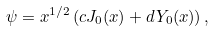<formula> <loc_0><loc_0><loc_500><loc_500>\psi = x ^ { 1 / 2 } \left ( c J _ { 0 } ( x ) + d Y _ { 0 } ( x ) \right ) ,</formula> 